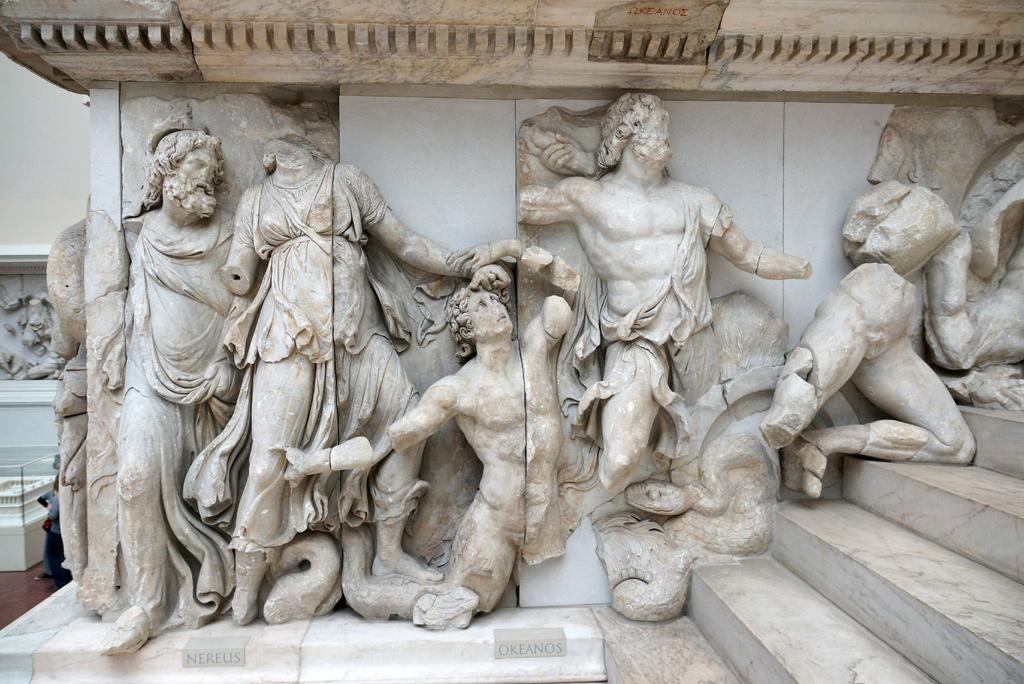What can be seen on the wall in the image? There is a wall with sculptures in the image. What architectural feature is on the right side of the image? There are stairs on the right side of the image. What is located on the left side of the image? There is a table on the floor on the left side of the image. Can you describe the person in the image? There is a person standing beside the table. What type of vegetable is being used as a fan in the image? There is no vegetable or fan present in the image. How does the expansion of the wall affect the sculptures in the image? The image does not show any expansion of the wall, and therefore it cannot affect the sculptures. 